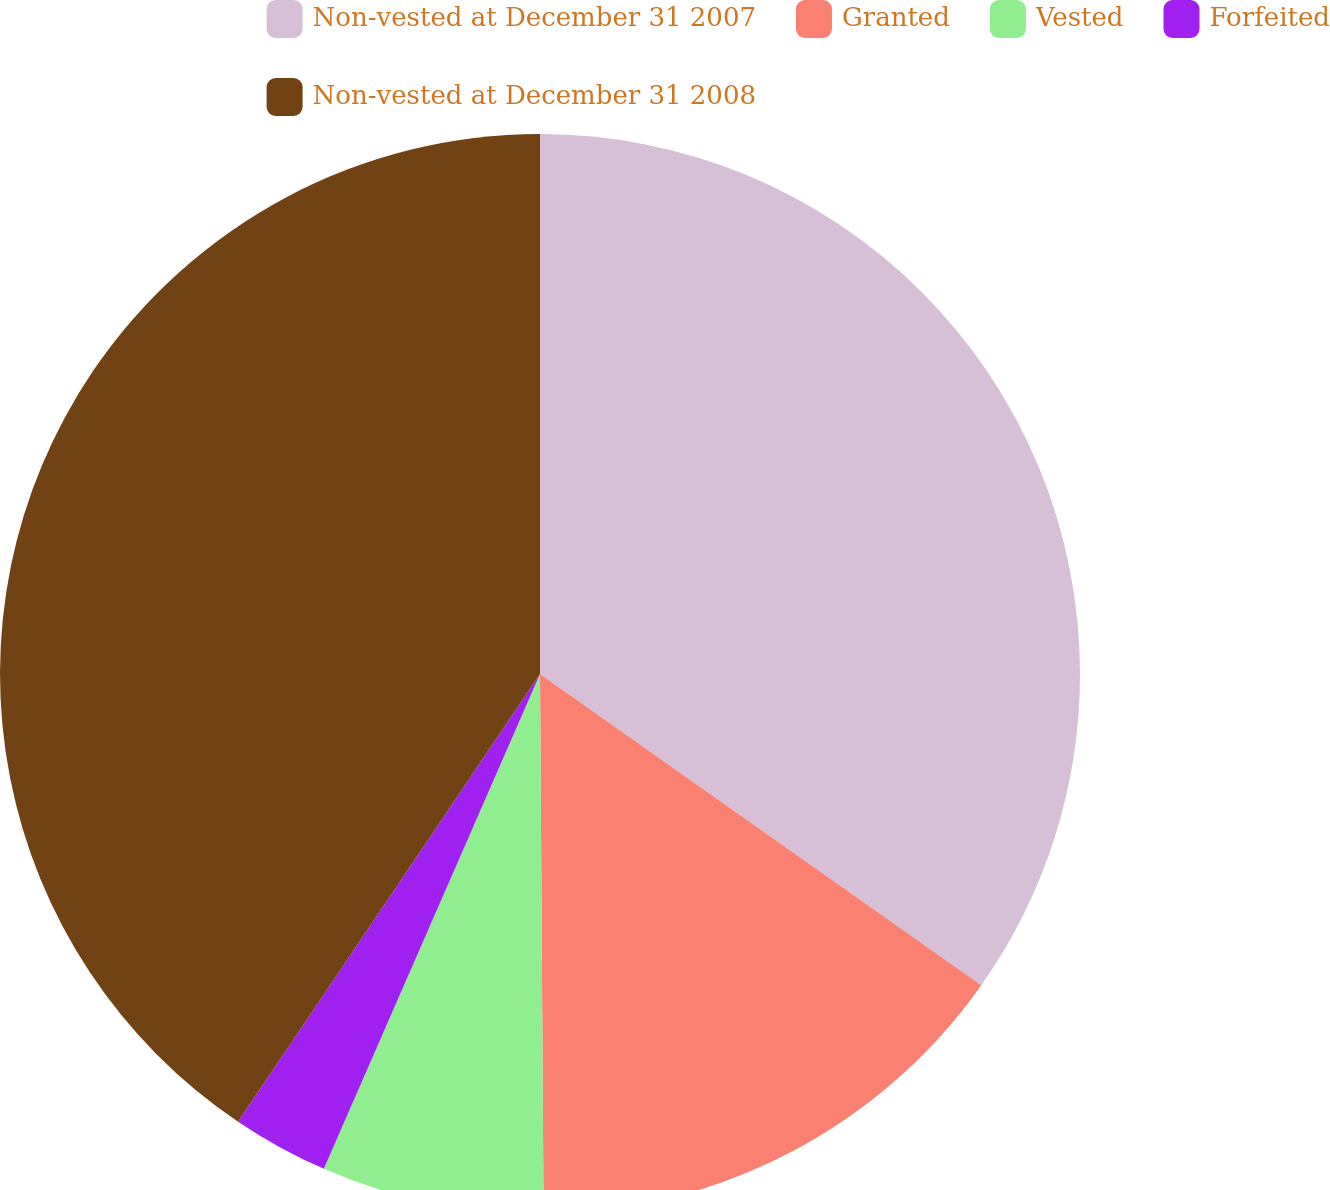<chart> <loc_0><loc_0><loc_500><loc_500><pie_chart><fcel>Non-vested at December 31 2007<fcel>Granted<fcel>Vested<fcel>Forfeited<fcel>Non-vested at December 31 2008<nl><fcel>34.78%<fcel>15.12%<fcel>6.66%<fcel>2.89%<fcel>40.56%<nl></chart> 